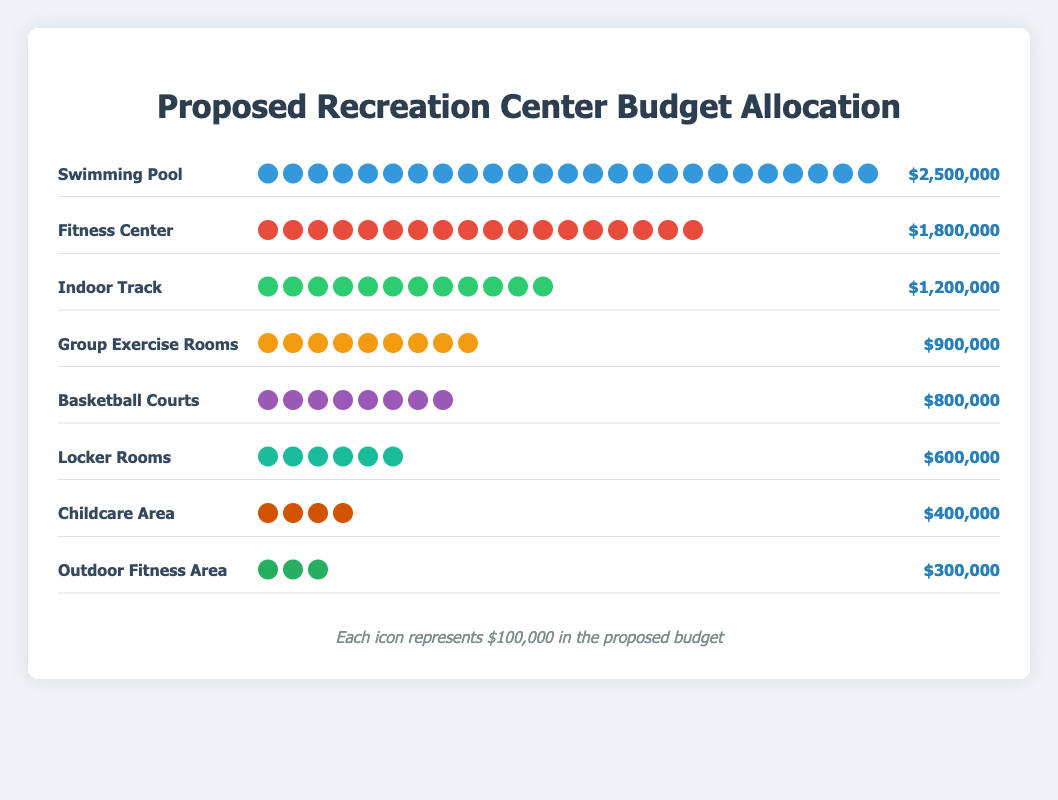What is the total budget allocated for the Fitness Center? The figure indicates that the Fitness Center has 18 icons, each representing $100,000. Thus, the total budget is 18 * $100,000.
Answer: $1,800,000 Which facility has the lowest budget allocation? By counting the icons, the Outdoor Fitness Area has the least with only 3 icons.
Answer: Outdoor Fitness Area How many more icons does the Swimming Pool have compared to the Childcare Area? The Swimming Pool has 25 icons, and the Childcare Area has 4 icons. The difference is 25 - 4.
Answer: 21 What is the combined budget allocation for Group Exercise Rooms and Basketball Courts? Group Exercise Rooms have 9 icons ($900,000), and Basketball Courts have 8 icons ($800,000). Combined, the budget is 900,000 + 800,000.
Answer: $1,700,000 Which facilities have an equal number of icons? Both the Childcare Area and the Outdoor Fitness Area have different numbers of icons, no facilities have the same number
Answer: None If the budgets for the Locker Rooms and Childcare Area were combined, where would this rank among the other facilities in terms of budget allocation? Locker Rooms have 6 icons ($600,000) and Childcare Area has 4 icons ($400,000). Combined, the budget is $600,000 + $400,000 = $1,000,000. Comparing this combined budget to the other facilities, it would rank between Indoor Track ($1,200,000) and Group Exercise Rooms ($900,000).
Answer: Between Indoor Track and Group Exercise Rooms What percentage of the total budget is allocated to the Swimming Pool? Total budget = $9,500,000. Budget for Swimming Pool = $2,500,000. Therefore, percentage = ($2,500,000 / $9,500,000) * 100.
Answer: 26.32% How much more budget is allocated to the Swimming Pool compared to the Basketball Courts? The budget for the Swimming Pool is $2,500,000 and for Basketball Courts is $800,000. The difference is $2,500,000 - $800,000.
Answer: $1,700,000 Which facility has the highest budget allocation and how much is it? The figure shows that the Swimming Pool has the most icons, with a total of 25 icons, which translates to the highest budget allocation of $2,500,000.
Answer: Swimming Pool, $2,500,000 